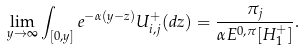Convert formula to latex. <formula><loc_0><loc_0><loc_500><loc_500>\lim _ { y \to \infty } \int _ { [ 0 , y ] } e ^ { - \alpha ( y - z ) } { U } ^ { + } _ { i , j } ( d z ) = \frac { \pi _ { j } } { \alpha E ^ { 0 , \pi } [ H ^ { + } _ { 1 } ] } .</formula> 